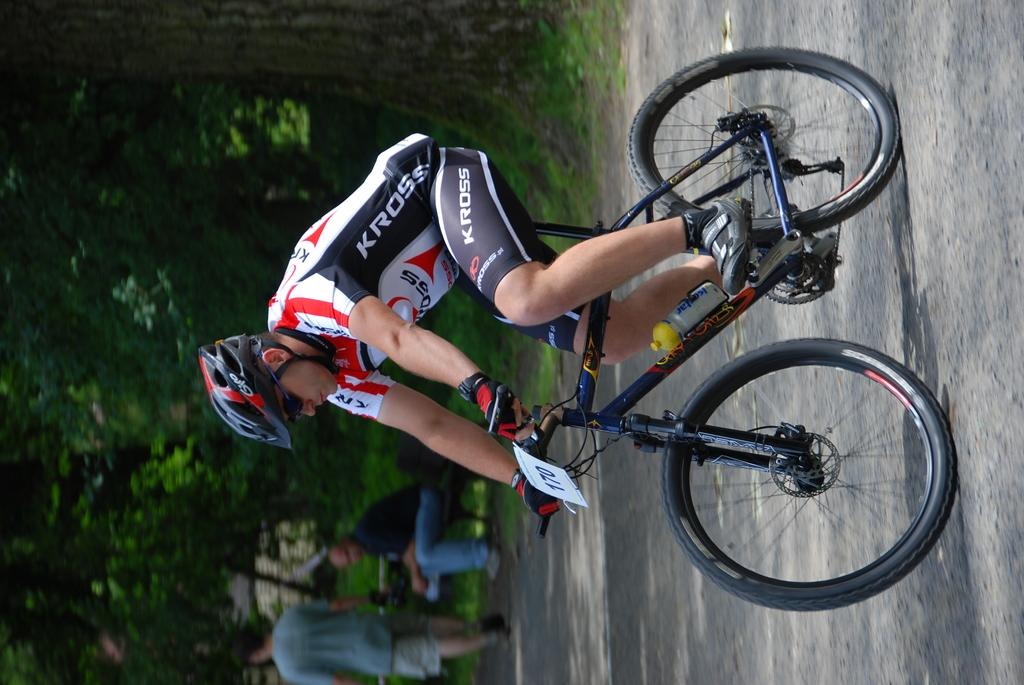What is happening in the image involving a group of people? There is a group of people in the image, but their specific activity is not mentioned in the facts. What is the man in the image doing? The man is riding a bicycle in the image. What safety precaution is the man taking while riding the bicycle? The man is wearing a helmet. What can be seen in the distance behind the people and the man on the bicycle? There are trees visible in the background of the image. What type of cherries are being used to measure the angle of the bicycle in the image? There are no cherries or angle measurements present in the image. What is the mysterious thing that appears to be floating in the background of the image? There is no mysterious thing or any indication of something floating in the background of the image. 